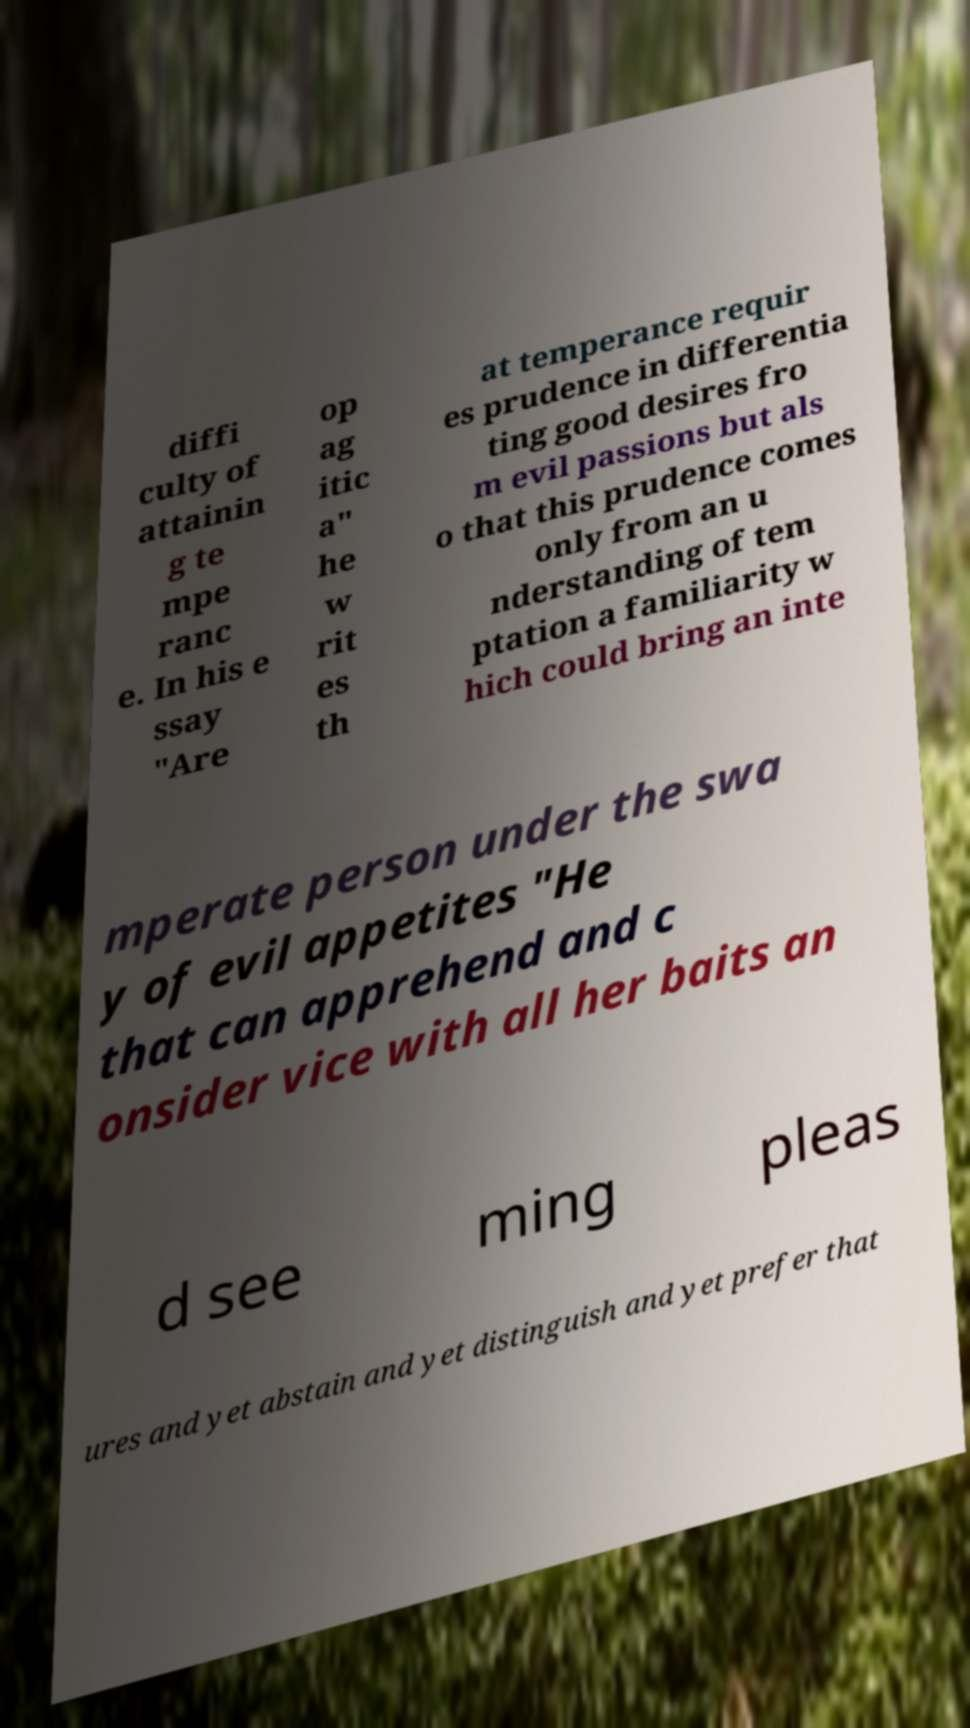Can you read and provide the text displayed in the image?This photo seems to have some interesting text. Can you extract and type it out for me? diffi culty of attainin g te mpe ranc e. In his e ssay "Are op ag itic a" he w rit es th at temperance requir es prudence in differentia ting good desires fro m evil passions but als o that this prudence comes only from an u nderstanding of tem ptation a familiarity w hich could bring an inte mperate person under the swa y of evil appetites "He that can apprehend and c onsider vice with all her baits an d see ming pleas ures and yet abstain and yet distinguish and yet prefer that 